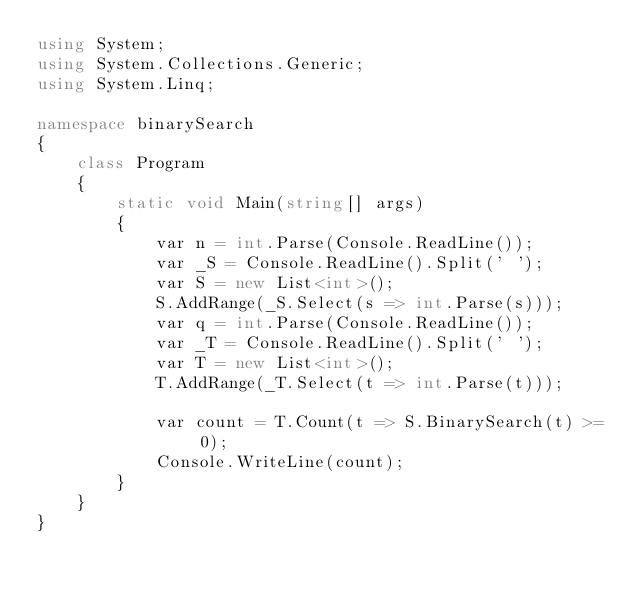<code> <loc_0><loc_0><loc_500><loc_500><_C#_>using System;
using System.Collections.Generic;
using System.Linq;

namespace binarySearch
{
    class Program
    {
        static void Main(string[] args)
        {
            var n = int.Parse(Console.ReadLine());
            var _S = Console.ReadLine().Split(' ');
            var S = new List<int>();
            S.AddRange(_S.Select(s => int.Parse(s)));
            var q = int.Parse(Console.ReadLine());
            var _T = Console.ReadLine().Split(' ');
            var T = new List<int>();
            T.AddRange(_T.Select(t => int.Parse(t)));

            var count = T.Count(t => S.BinarySearch(t) >= 0);
            Console.WriteLine(count);
        }
    }
}</code> 